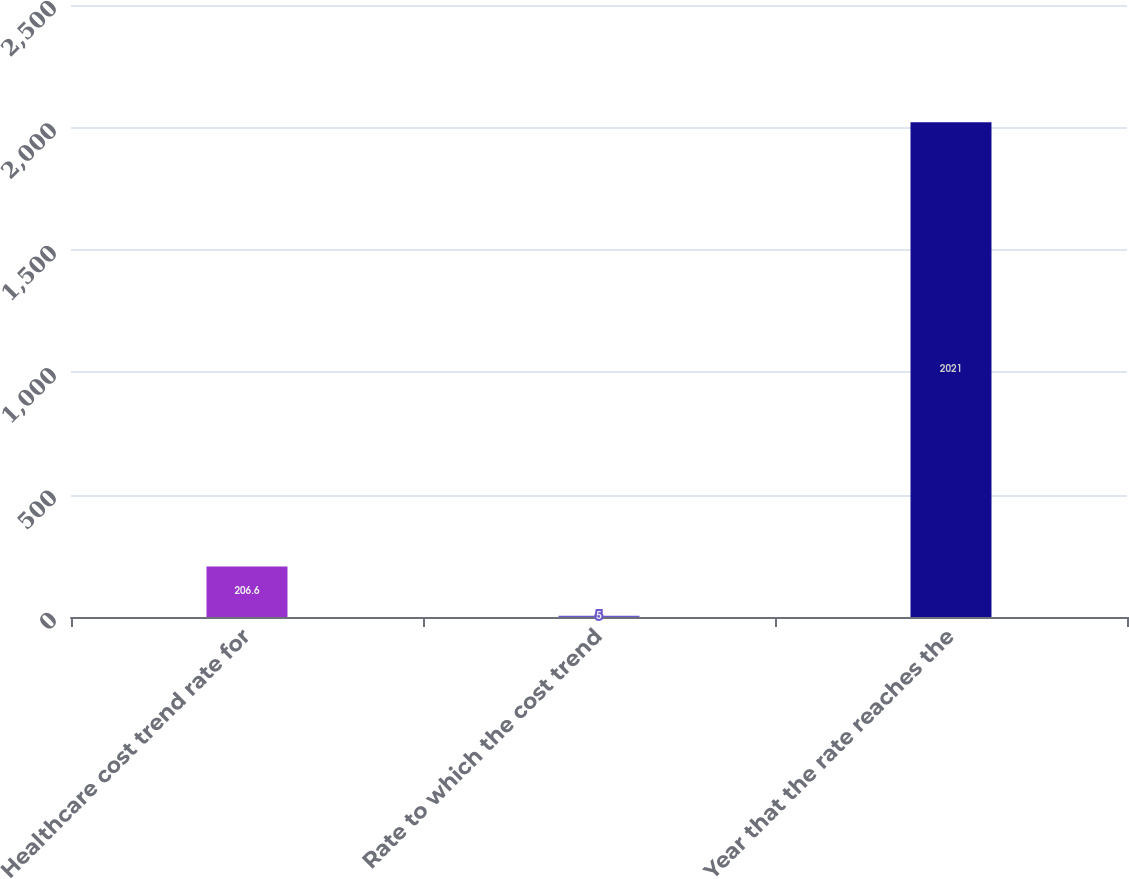Convert chart. <chart><loc_0><loc_0><loc_500><loc_500><bar_chart><fcel>Healthcare cost trend rate for<fcel>Rate to which the cost trend<fcel>Year that the rate reaches the<nl><fcel>206.6<fcel>5<fcel>2021<nl></chart> 